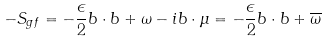Convert formula to latex. <formula><loc_0><loc_0><loc_500><loc_500>- S _ { g f } = - \frac { \epsilon } { 2 } b \cdot b + \omega - i b \cdot \mu = - \frac { \epsilon } { 2 } b \cdot b + \overline { \omega }</formula> 